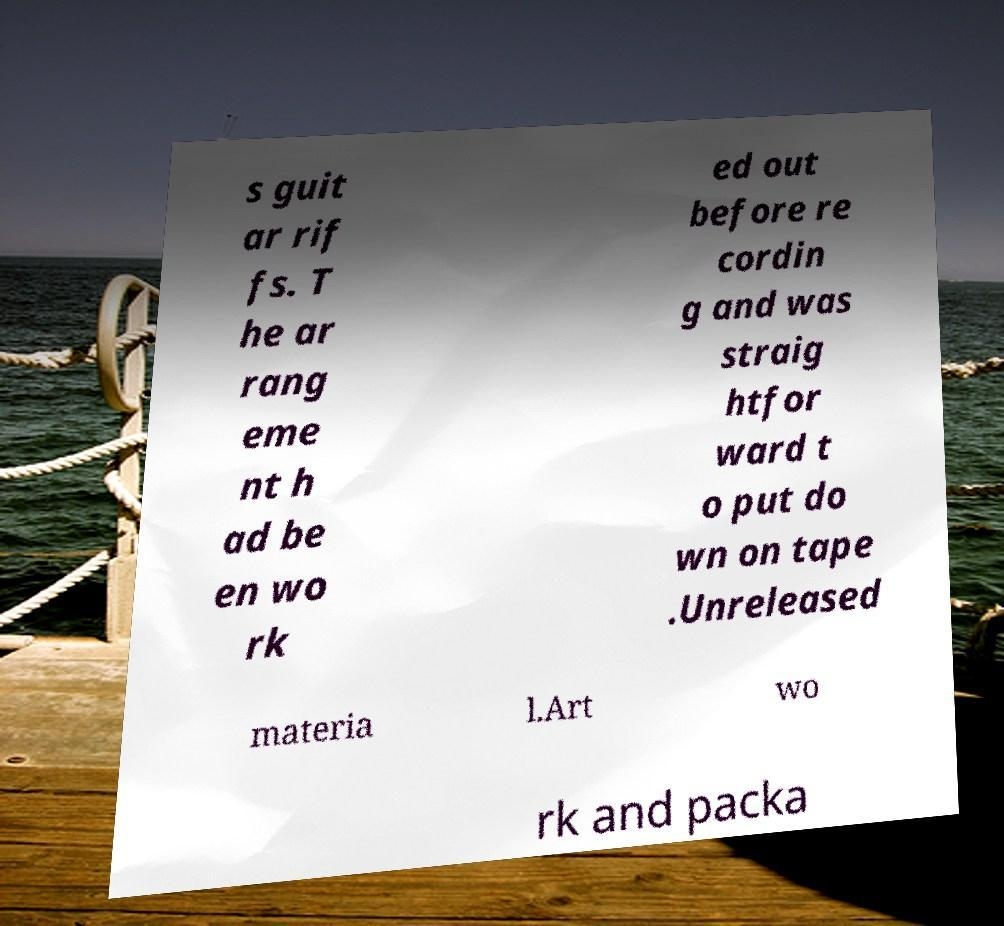Can you accurately transcribe the text from the provided image for me? s guit ar rif fs. T he ar rang eme nt h ad be en wo rk ed out before re cordin g and was straig htfor ward t o put do wn on tape .Unreleased materia l.Art wo rk and packa 